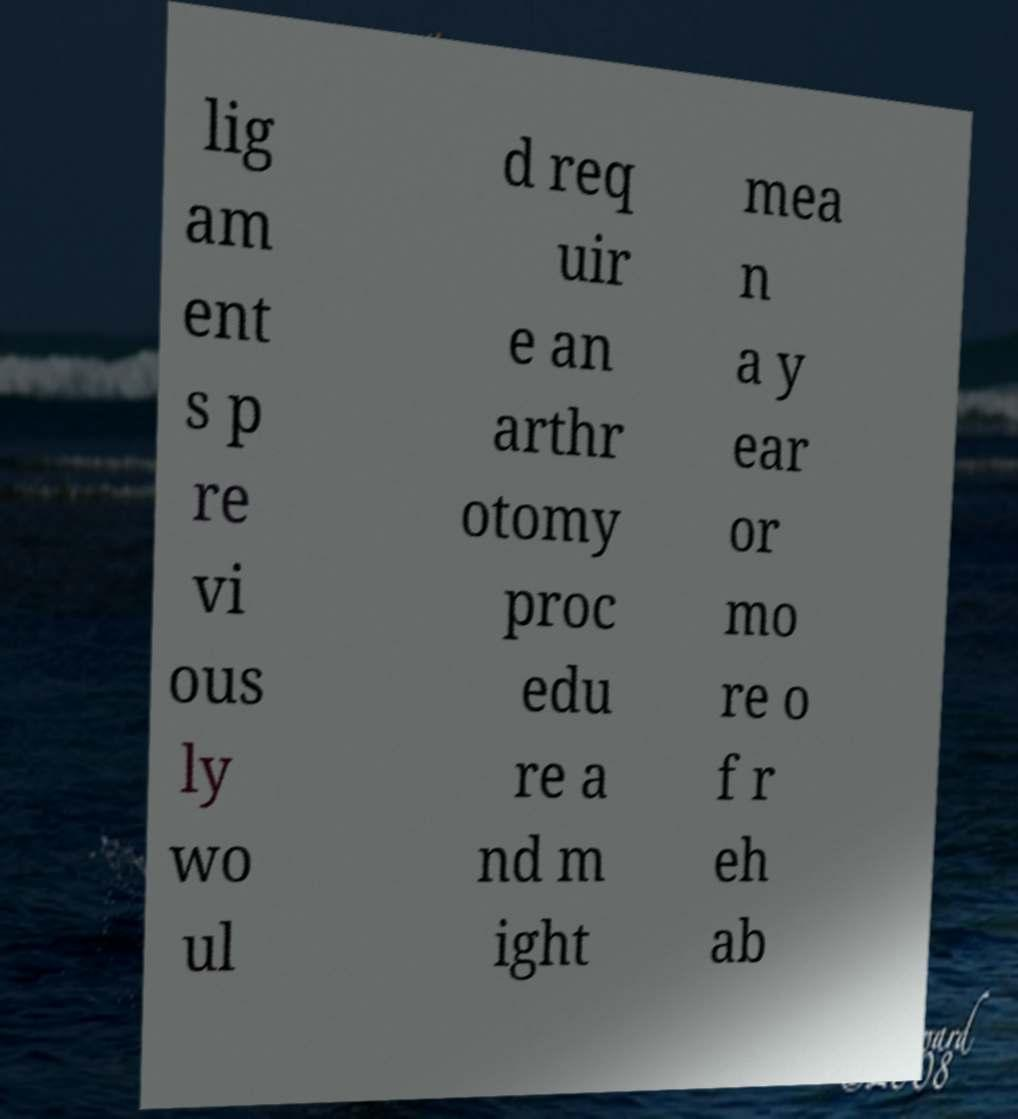Could you extract and type out the text from this image? lig am ent s p re vi ous ly wo ul d req uir e an arthr otomy proc edu re a nd m ight mea n a y ear or mo re o f r eh ab 